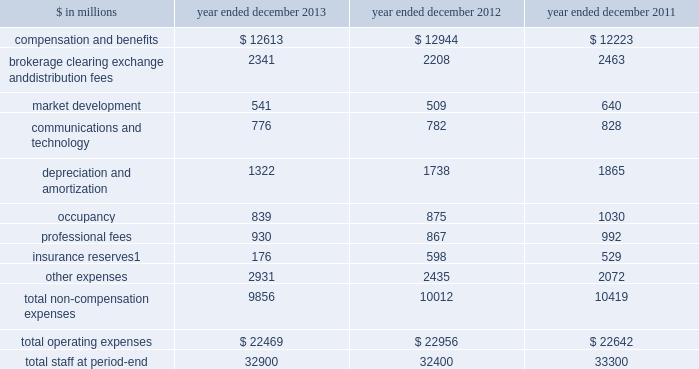Management 2019s discussion and analysis net interest income 2013 versus 2012 .
Net interest income on the consolidated statements of earnings was $ 3.39 billion for 2013 , 13% ( 13 % ) lower than 2012 .
The decrease compared with 2012 was primarily due to lower average yields on financial instruments owned , at fair value , partially offset by lower interest expense on financial instruments sold , but not yet purchased , at fair value and collateralized financings .
2012 versus 2011 .
Net interest income on the consolidated statements of earnings was $ 3.88 billion for 2012 , 25% ( 25 % ) lower than 2011 .
The decrease compared with 2011 was primarily due to lower average yields on financial instruments owned , at fair value and collateralized agreements .
See 201cstatistical disclosures 2014 distribution of assets , liabilities and shareholders 2019 equity 201d for further information about our sources of net interest income .
Operating expenses our operating expenses are primarily influenced by compensation , headcount and levels of business activity .
Compensation and benefits includes salaries , discretionary compensation , amortization of equity awards and other items such as benefits .
Discretionary compensation is significantly impacted by , among other factors , the level of net revenues , overall financial performance , prevailing labor markets , business mix , the structure of our share-based compensation programs and the external environment .
The table below presents our operating expenses and total staff ( which includes employees , consultants and temporary staff ) . .
Related revenues are included in 201cmarket making 201d in the consolidated statements of earnings .
Goldman sachs 2013 annual report 45 .
What is the percentage change in staff number in 2013? 
Computations: ((32900 - 32400) / 32400)
Answer: 0.01543. 